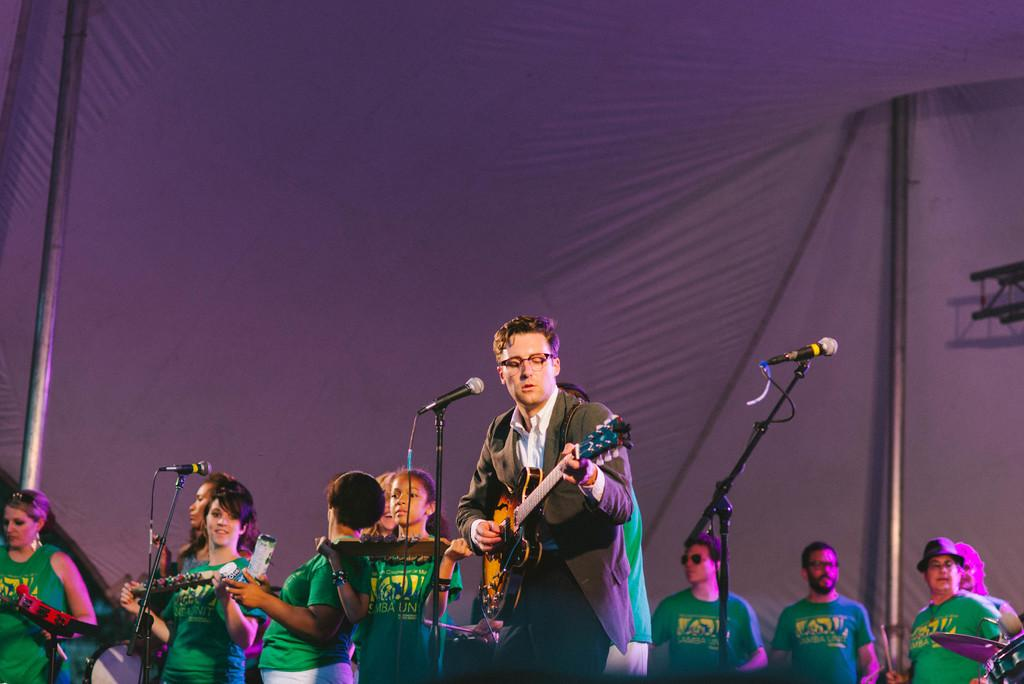What are the persons in the image doing? The persons in the image are playing musical instruments. Can you describe the attire of one of the persons? One person is wearing a suit. What accessory does the person in the suit have? The person in the suit has spectacles. What equipment is present for amplifying sound in the image? There are microphones (mikes) in the image. What vertical structure can be seen in the image? There is a pole in the image. Reasoning: Let' Let's think step by step in order to produce the conversation. We start by identifying the main activity in the image, which is the persons playing musical instruments. Then, we describe the appearance of one of the persons, focusing on their attire and accessories. Next, we mention the equipment used for amplifying sound, which are the microphones. Finally, we identify a vertical structure present in the image, which is the pole. Absurd Question/Answer: What type of berry is being used as a percussion instrument in the image? There is no berry present in the image, let alone being used as a percussion instrument. 